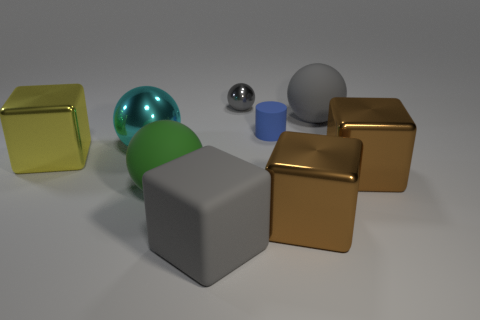Is the size of the yellow cube the same as the gray matte cube?
Offer a terse response. Yes. There is a large cyan thing that is the same shape as the gray metal thing; what is its material?
Make the answer very short. Metal. Are there any other things that have the same material as the large gray sphere?
Your response must be concise. Yes. What number of purple objects are either rubber spheres or large cubes?
Provide a short and direct response. 0. There is a large ball that is to the right of the gray cube; what is it made of?
Provide a short and direct response. Rubber. Are there more large brown shiny things than tiny red metallic cylinders?
Make the answer very short. Yes. There is a tiny thing on the left side of the blue thing; is its shape the same as the green matte object?
Your response must be concise. Yes. How many shiny objects are in front of the gray metal thing and to the right of the large shiny sphere?
Provide a short and direct response. 2. What number of blue objects have the same shape as the tiny gray metal object?
Keep it short and to the point. 0. The rubber ball that is behind the metal cube on the left side of the large rubber cube is what color?
Give a very brief answer. Gray. 